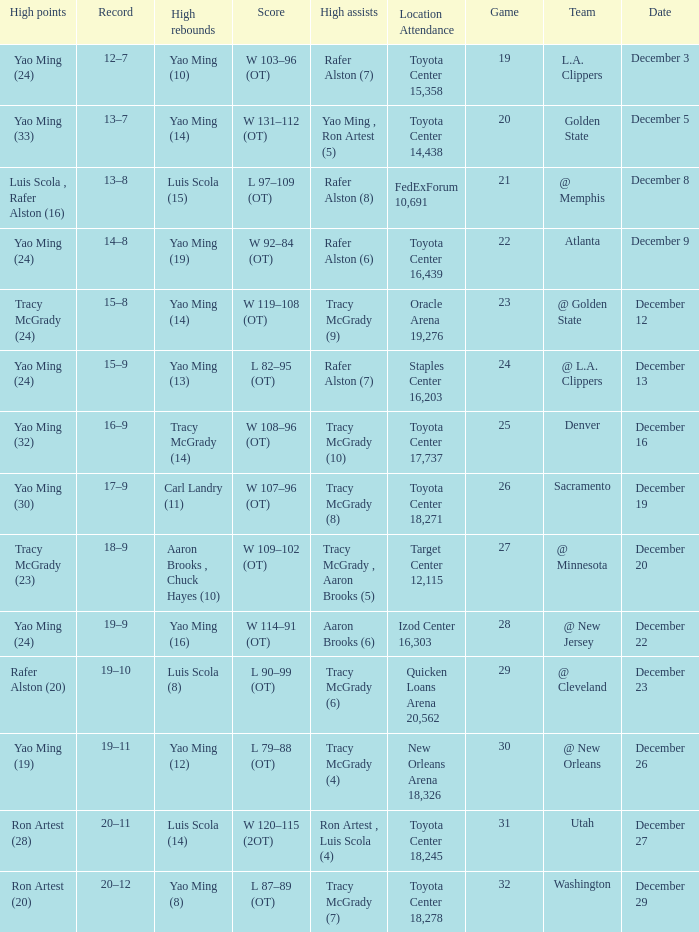When aaron brooks (6) had the highest amount of assists what is the date? December 22. 